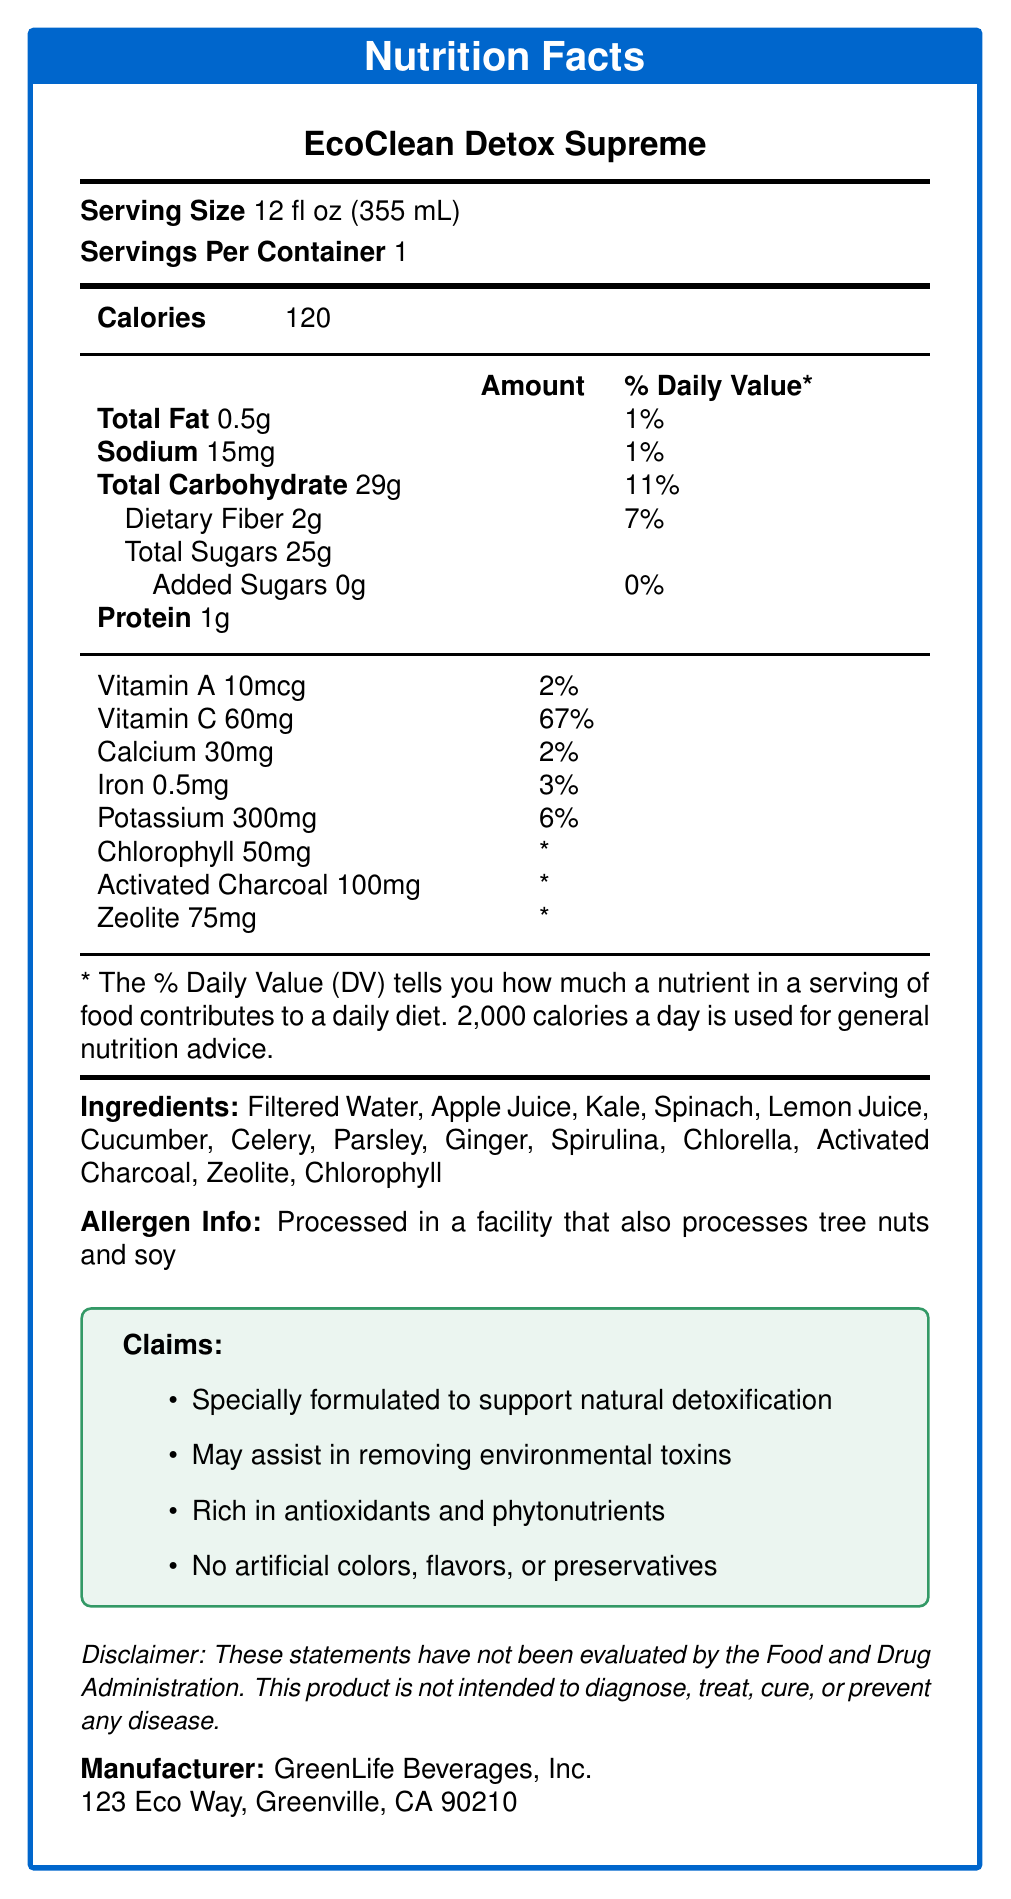what is the serving size of EcoClean Detox Supreme? The serving size is explicitly mentioned in the document as "Serving Size 12 fl oz (355 mL)".
Answer: 12 fl oz (355 mL) how many calories are in one serving? The document states the number of calories in one serving as "Calories 120".
Answer: 120 calories how much dietary fiber does this juice contain? The document lists "Dietary Fiber 2g" under total carbohydrates.
Answer: 2g are there any added sugars in this product? The document specifies "Added Sugars 0g", indicating there are no added sugars.
Answer: No what is the main ingredient in the EcoClean Detox Supreme juice? The ingredients are listed in order of predominance, and "Filtered Water" is the first ingredient mentioned.
Answer: Filtered Water which ingredient contains the highest daily value percentage of a nutrient? A. Vitamin A B. Vitamin C C. Calcium D. Iron The document states "Vitamin C 67%" which is the highest daily value percentage among the listed ingredients.
Answer: B. Vitamin C how many milligrams of sodium does the juice contain? The nutritional breakdown includes "Sodium 15mg".
Answer: 15mg what is the total carbohydrate content, and what percentage of the daily value does it represent? The document specifies "Total Carbohydrate 29g" and indicates this is 11% of the daily value.
Answer: 29g, 11% what company manufactures EcoClean Detox Supreme? The document states the manufacturer as "GreenLife Beverages, Inc."
Answer: GreenLife Beverages, Inc. does this product contain any artificial colors, flavors, or preservatives? One of the claims explicitly states "No artificial colors, flavors, or preservatives".
Answer: No Does the juice have a high protein content? The document specifies the juice only contains 1g of protein.
Answer: No Identify if the statement is true or false: "This juice assists in removing environmental toxins." One of the claims listed in the document is that the juice "May assist in removing environmental toxins".
Answer: True summarize the main information provided in the document. The document provides comprehensive nutritional information for EcoClean Detox Supreme, detailing its ingredients, nutritional values, benefits, and manufacturer information.
Answer: The document is a Nutrition Facts label for EcoClean Detox Supreme juice. It details serving size, nutritional content, ingredients, allergen information, claims about detoxification properties, and manufacturer details. It highlights that the juice supports natural detoxification, contains no artificial additives, and provides a breakdown of its vitamins, minerals, and other components. There are disclaimers about the non-evaluated health claims and the processing facility. what environmental benefits are claimed by this product? The document only claims that the juice "May assist in removing environmental toxins" but does not provide specific environmental benefits or evidence for this claim.
Answer: Cannot be determined 